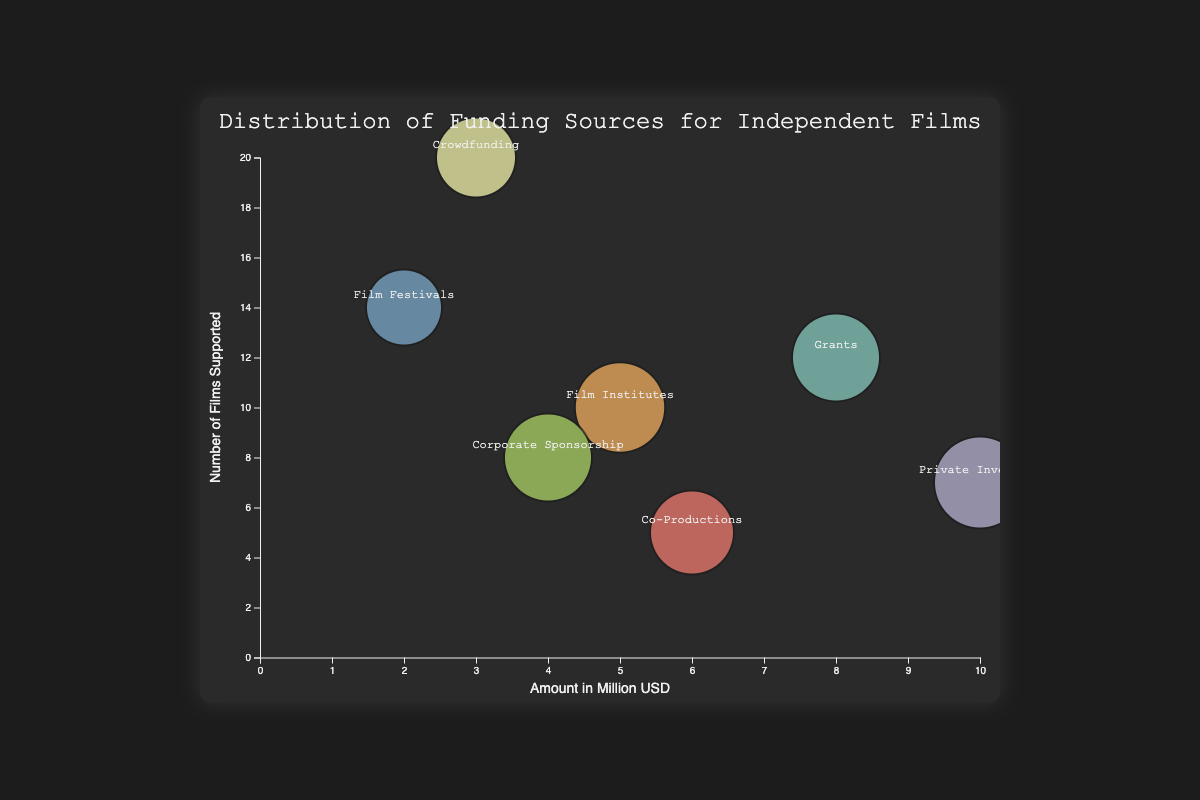What is the title of the chart? The title is displayed at the top of the chart and provides a summary of what the chart depicts.
Answer: Distribution of Funding Sources for Independent Films Which funding source supports the most number of films? Look at the vertical axis to determine the highest value and then identify the corresponding funding source label.
Answer: Crowdfunding How much funding did Private Investors provide? Locate the 'Private Investors' bubble, refer to its position on the horizontal axis, which represents the amount in million USD.
Answer: 10 million USD What is the source reliability of Film Institutes? Locate the 'Film Institutes' bubble, observe its size which indicates source reliability, and use the legend or bubble size as a key.
Answer: 0.88 Which funding source has the smallest amount of funding? Identify the bubble that is positioned furthest to the left on the horizontal axis, representing the smallest amount in million USD, and check its label.
Answer: Film Festivals How many films are supported by both Film Institutes and Corporate Sponsorship combined? Locate the bubbles for Film Institutes and Corporate Sponsorship, check their values on the vertical axis, and add them together. 10 + 8 equals 18.
Answer: 18 Which funding source has higher reliability: Grants or Co-Productions? Compare the sizes of the 'Grants' and 'Co-Productions' bubbles. The size of the bubble represents reliability.
Answer: Grants How does the funding amount of Crowdfunding compare with Co-Productions? Locate both bubbles on the horizontal axis and compare their positions. Crowdfunding is at 3 and Co-Productions is at 6.
Answer: Co-Productions provide twice the amount as Crowdfunding What is the average amount of funding from all sources? Add the funding amounts from all sources (8 + 3 + 10 + 6 + 2 + 5 + 4 = 38), and divide by the number of sources (7). The average funding amount is 38 / 7 = 5.43.
Answer: 5.43 million USD Arrange the funding sources in order of their reliability. Compare the sizes of all bubbles and list the sources from largest to smallest size: Private Investors, Film Institutes, Grants, Corporate Sponsorship, Co-Productions, Crowdfunding, Film Festivals.
Answer: Private Investors, Film Institutes, Grants, Corporate Sponsorship, Co-Productions, Crowdfunding, Film Festivals 